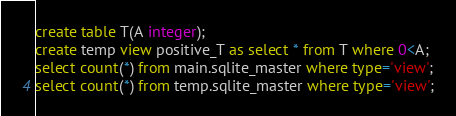<code> <loc_0><loc_0><loc_500><loc_500><_SQL_>create table T(A integer);
create temp view positive_T as select * from T where 0<A;
select count(*) from main.sqlite_master where type='view';
select count(*) from temp.sqlite_master where type='view';

</code> 